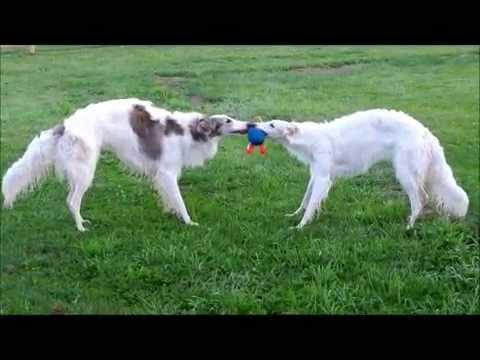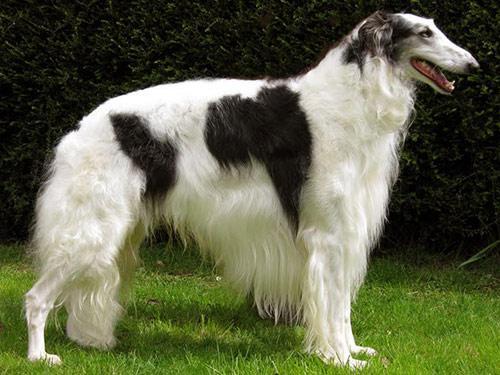The first image is the image on the left, the second image is the image on the right. Analyze the images presented: Is the assertion "There is a human holding a dog's leash." valid? Answer yes or no. No. The first image is the image on the left, the second image is the image on the right. Given the left and right images, does the statement "In one of the images, a single white dog with no dark patches has its mouth open and is standing in green grass facing rightward." hold true? Answer yes or no. No. 